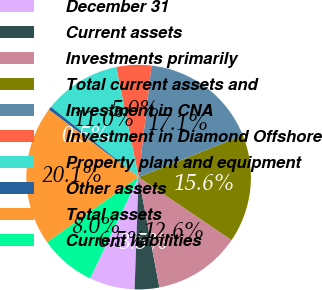Convert chart. <chart><loc_0><loc_0><loc_500><loc_500><pie_chart><fcel>December 31<fcel>Current assets<fcel>Investments primarily<fcel>Total current assets and<fcel>Investment in CNA<fcel>Investment in Diamond Offshore<fcel>Property plant and equipment<fcel>Other assets<fcel>Total assets<fcel>Current liabilities<nl><fcel>6.54%<fcel>3.53%<fcel>12.56%<fcel>15.57%<fcel>17.08%<fcel>5.03%<fcel>11.05%<fcel>0.51%<fcel>20.09%<fcel>8.04%<nl></chart> 